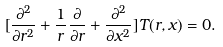Convert formula to latex. <formula><loc_0><loc_0><loc_500><loc_500>[ \frac { \partial ^ { 2 } } { \partial r ^ { 2 } } + \frac { 1 } { r } \frac { \partial } { \partial r } + \frac { \partial ^ { 2 } } { \partial x ^ { 2 } } ] T ( r , x ) = 0 .</formula> 